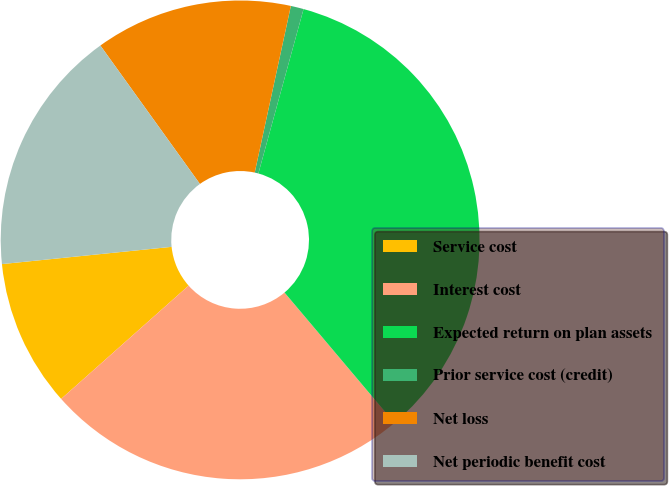<chart> <loc_0><loc_0><loc_500><loc_500><pie_chart><fcel>Service cost<fcel>Interest cost<fcel>Expected return on plan assets<fcel>Prior service cost (credit)<fcel>Net loss<fcel>Net periodic benefit cost<nl><fcel>9.95%<fcel>24.59%<fcel>34.58%<fcel>0.87%<fcel>13.32%<fcel>16.69%<nl></chart> 